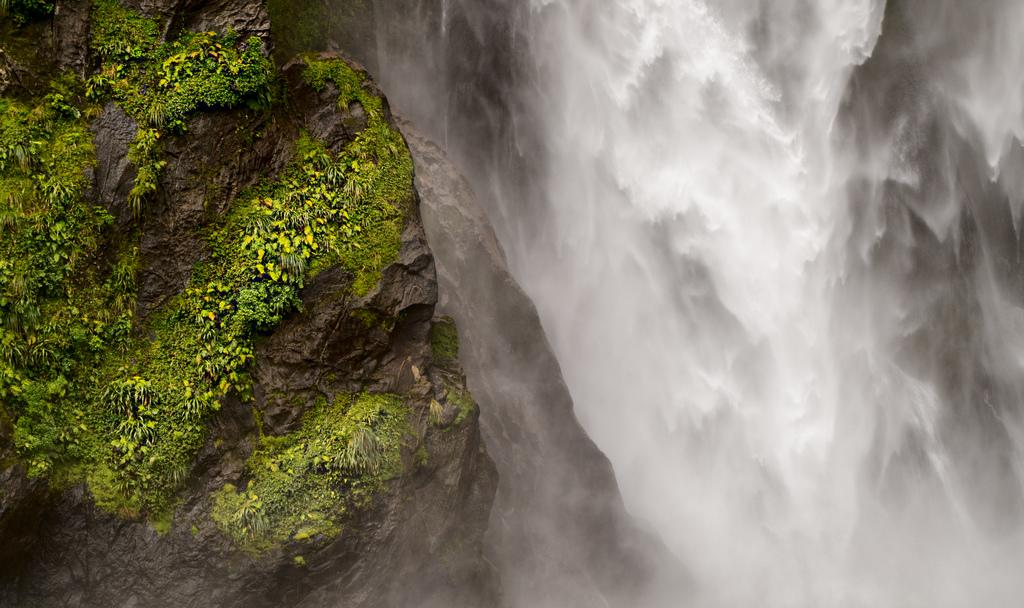What natural feature is the main subject of the image? There is a waterfall in the image. What is located behind the waterfall? There is a rock behind the waterfall. What is growing on the rock? There is algae on the rock. What type of glue is being used to hold the bricks together in the image? There are no bricks or glue present in the image; it features a waterfall and a rock with algae. 